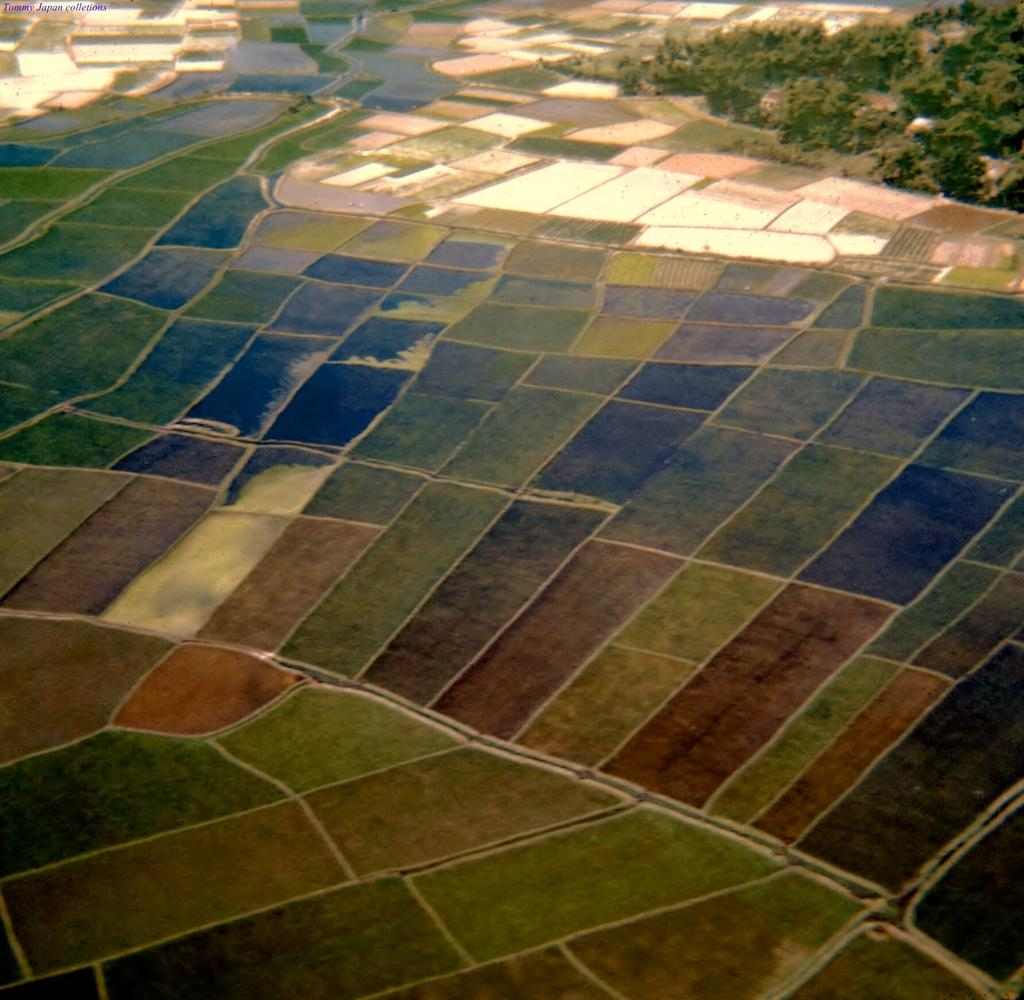What type of flooring is depicted in the image? There are different colors of tiles in the image. Can you describe the background of the image? There are plants in the background on the right side of the image. How many robins can be seen sitting on the tiles in the image? There are no robins present in the image; it only features tiles and plants in the background. 